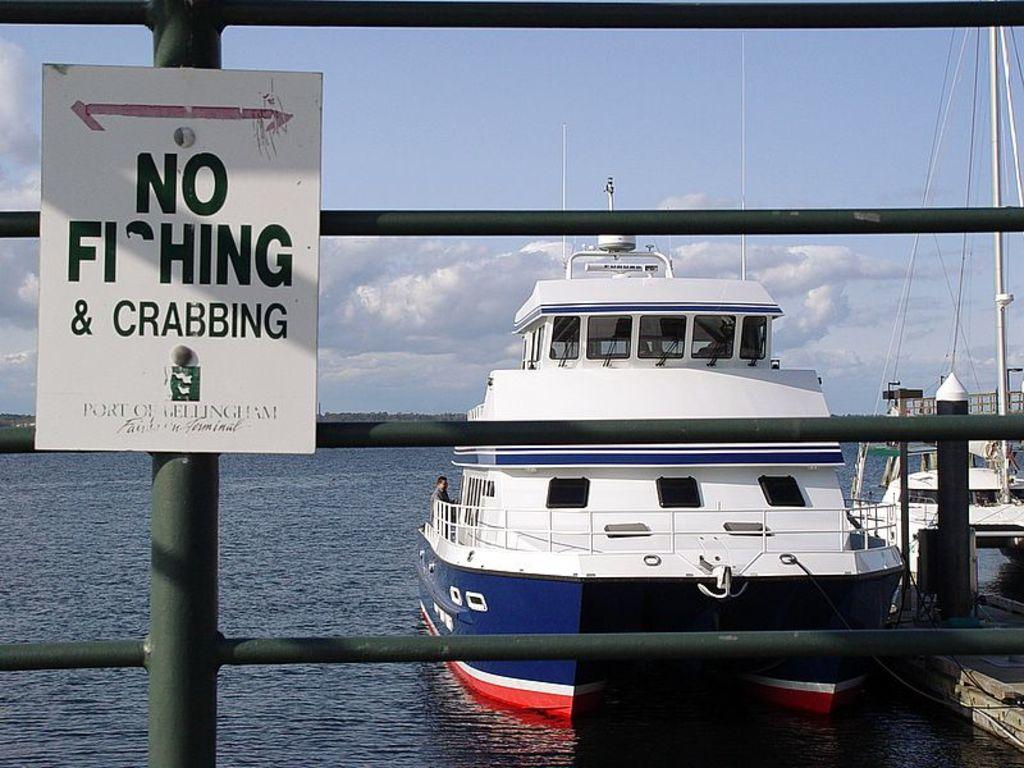What is located on the left side of the image? There is a board on the left side of the image. What can be seen in the middle of the image? There are boats in the middle of the image. What type of surface is visible at the bottom of the image? There is water visible at the bottom of the image. What is visible at the top of the image? The sky is visible at the top of the image. Can you tell me how many people are smiling in the image? There are no people present in the image, so it is not possible to determine how many people might be smiling. Where is the calendar located in the image? There is no calendar present in the image. 